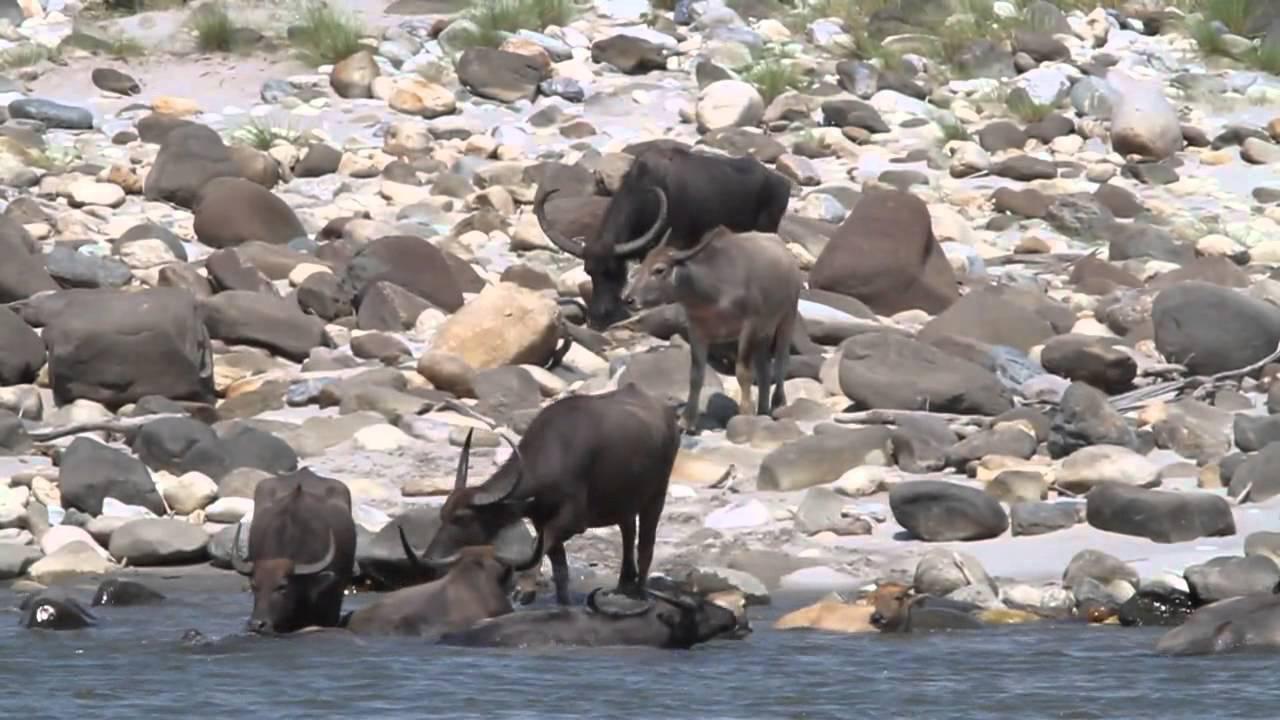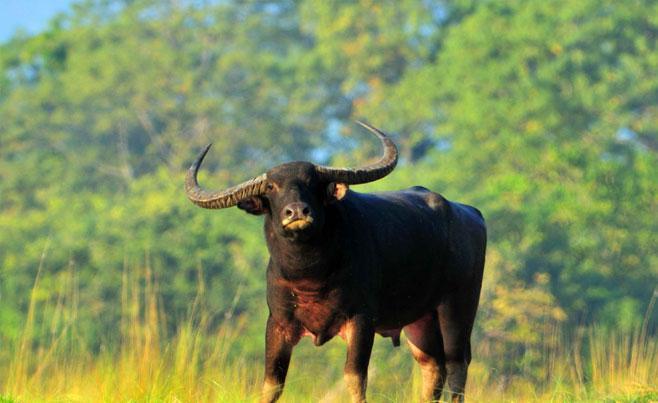The first image is the image on the left, the second image is the image on the right. Evaluate the accuracy of this statement regarding the images: "The left image contains one water buffalo looking directly at the camera, and the right image includes a water bufflao with a cord threaded through its nose.". Is it true? Answer yes or no. No. The first image is the image on the left, the second image is the image on the right. Analyze the images presented: Is the assertion "there is at least on animal standing on a path" valid? Answer yes or no. No. 